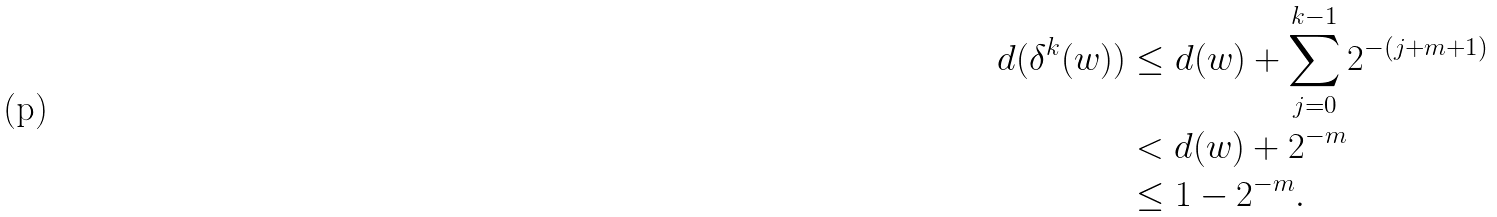<formula> <loc_0><loc_0><loc_500><loc_500>d ( \delta ^ { k } ( w ) ) & \leq d ( w ) + \sum _ { j = 0 } ^ { k - 1 } 2 ^ { - ( j + m + 1 ) } \\ & < d ( w ) + 2 ^ { - m } \\ & \leq 1 - 2 ^ { - m } .</formula> 